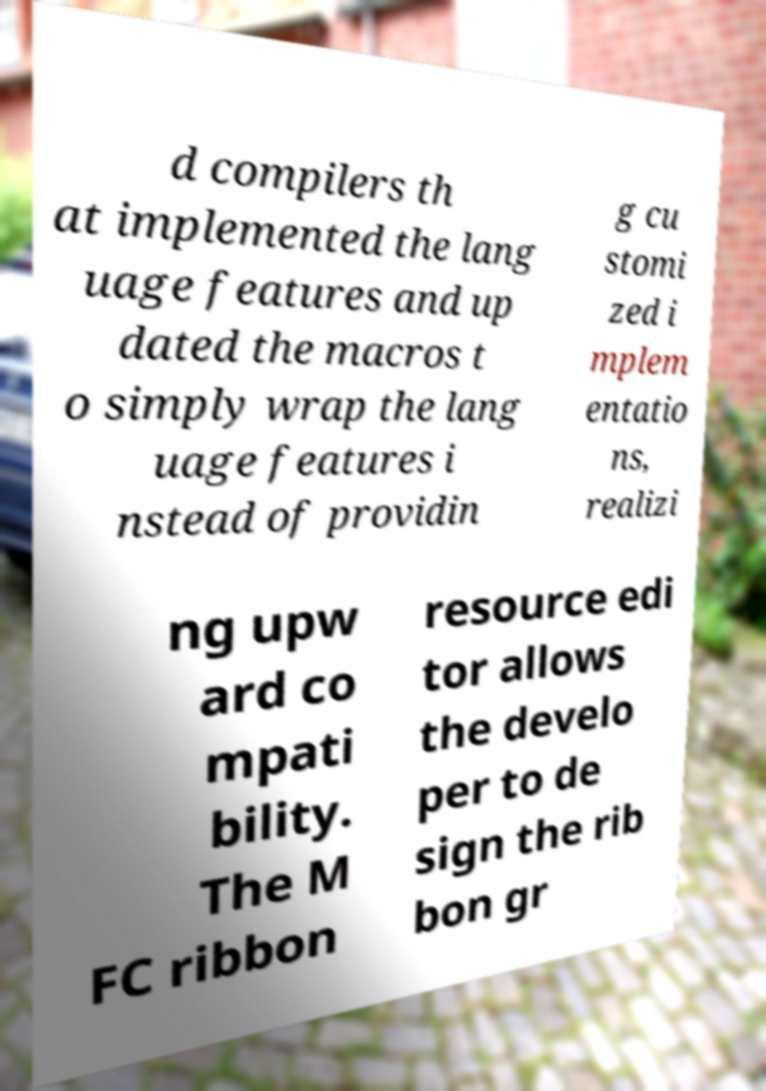Please read and relay the text visible in this image. What does it say? d compilers th at implemented the lang uage features and up dated the macros t o simply wrap the lang uage features i nstead of providin g cu stomi zed i mplem entatio ns, realizi ng upw ard co mpati bility. The M FC ribbon resource edi tor allows the develo per to de sign the rib bon gr 